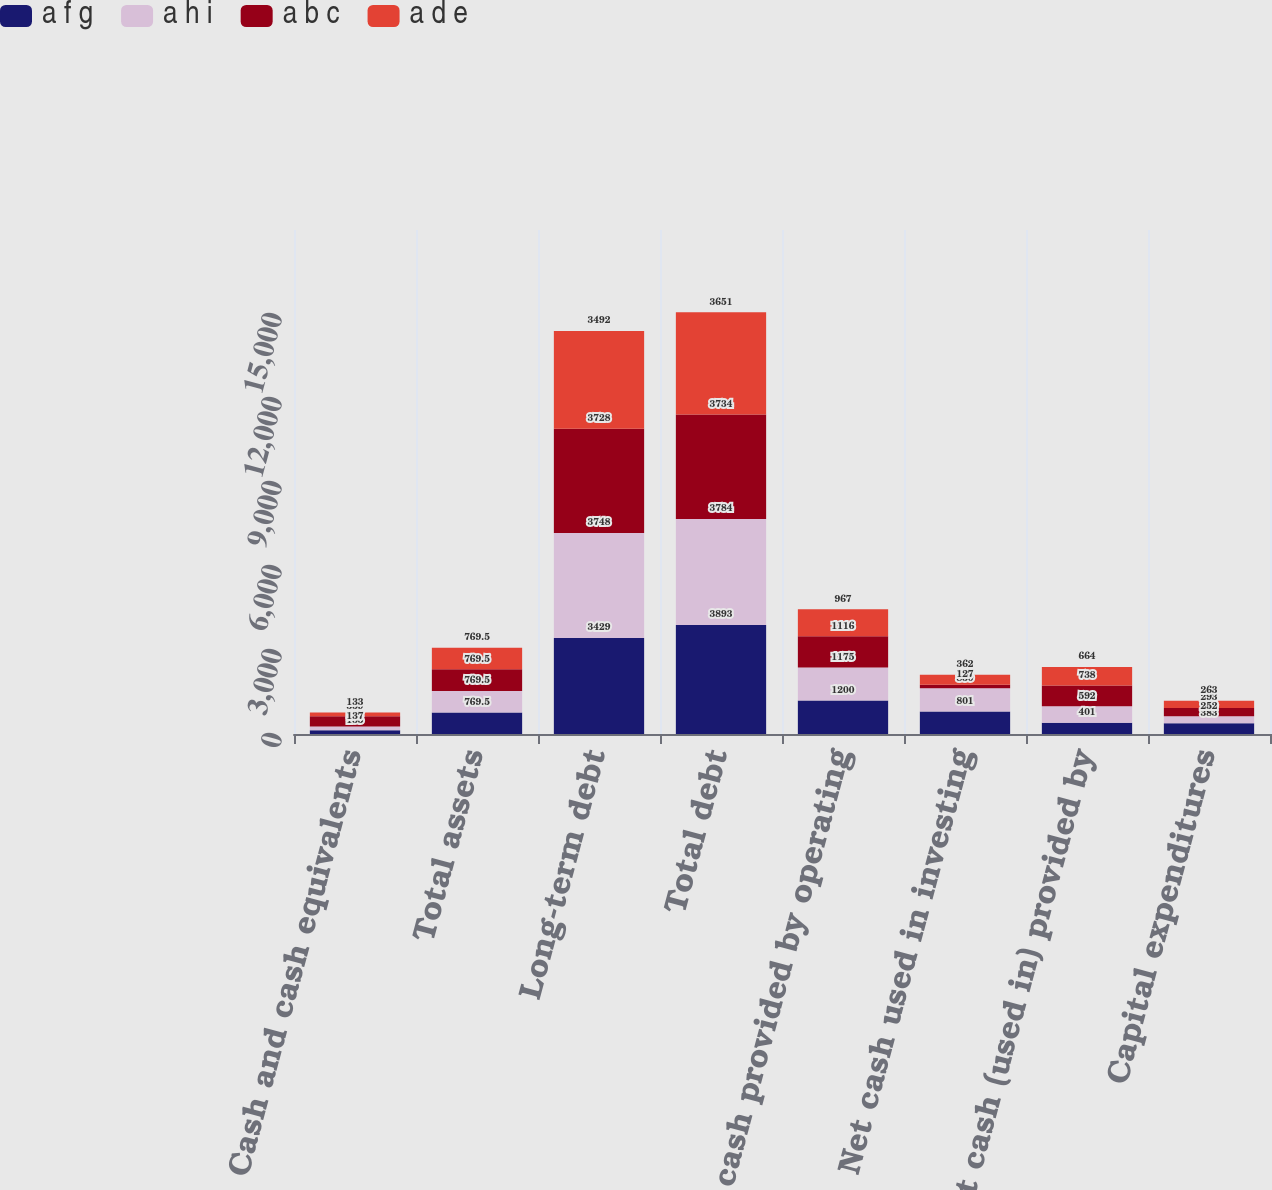Convert chart to OTSL. <chart><loc_0><loc_0><loc_500><loc_500><stacked_bar_chart><ecel><fcel>Cash and cash equivalents<fcel>Total assets<fcel>Long-term debt<fcel>Total debt<fcel>Net cash provided by operating<fcel>Net cash used in investing<fcel>Net cash (used in) provided by<fcel>Capital expenditures<nl><fcel>a f g<fcel>135<fcel>769.5<fcel>3429<fcel>3893<fcel>1200<fcel>801<fcel>401<fcel>383<nl><fcel>a h i<fcel>137<fcel>769.5<fcel>3748<fcel>3784<fcel>1175<fcel>830<fcel>592<fcel>252<nl><fcel>a b c<fcel>359<fcel>769.5<fcel>3728<fcel>3734<fcel>1116<fcel>127<fcel>738<fcel>293<nl><fcel>a d e<fcel>133<fcel>769.5<fcel>3492<fcel>3651<fcel>967<fcel>362<fcel>664<fcel>263<nl></chart> 